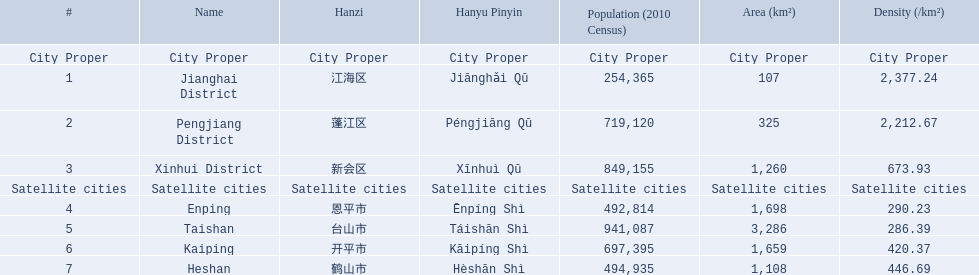What metropolitan areas are included? Jianghai District, Pengjiang District, Xinhui District. Which possesses the smallest expanse in km2? Jianghai District. 